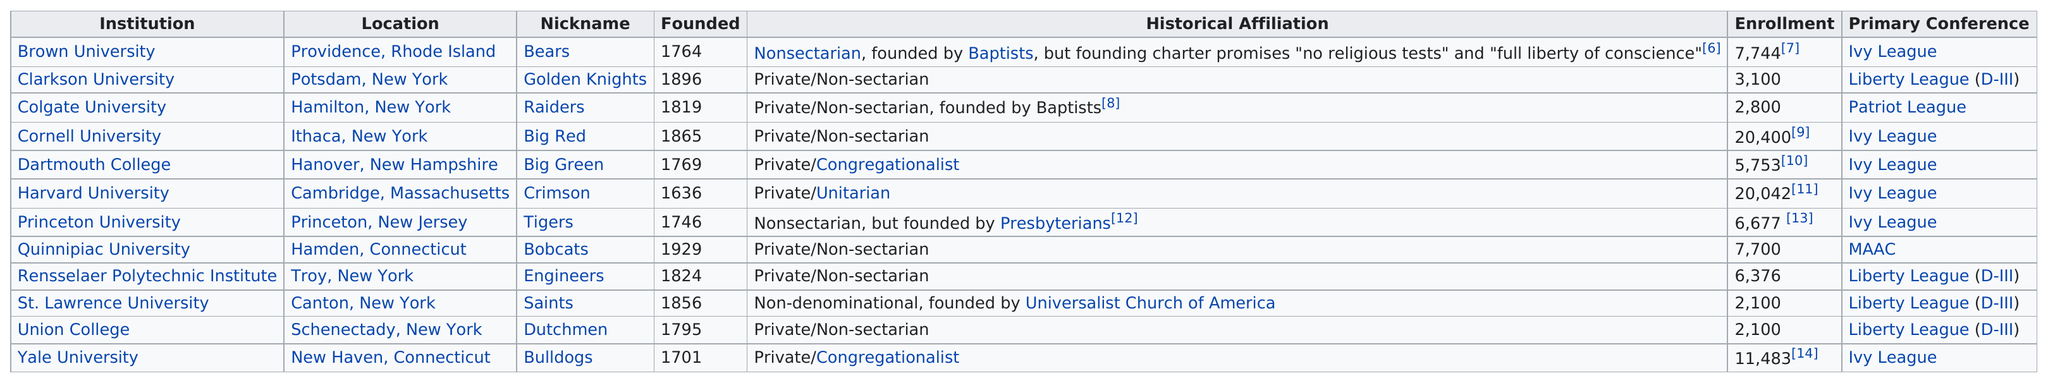Mention a couple of crucial points in this snapshot. Cornell University has the most enrollment among all institutions. St. Lawrence College, known for its saints as its nickname, had a reputation for excellence in education. Eight institutions are non-denominational or non-sectarian. The total enrollment when adding Brown University and Union College would be 9,844. Out of the total number of institutions, 9% have a private historical affiliation. 